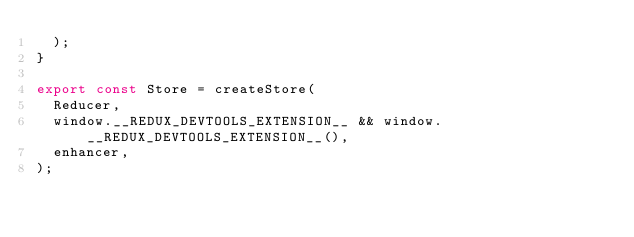<code> <loc_0><loc_0><loc_500><loc_500><_JavaScript_>  );
}

export const Store = createStore(
  Reducer,
  window.__REDUX_DEVTOOLS_EXTENSION__ && window.__REDUX_DEVTOOLS_EXTENSION__(),
  enhancer,
);
</code> 